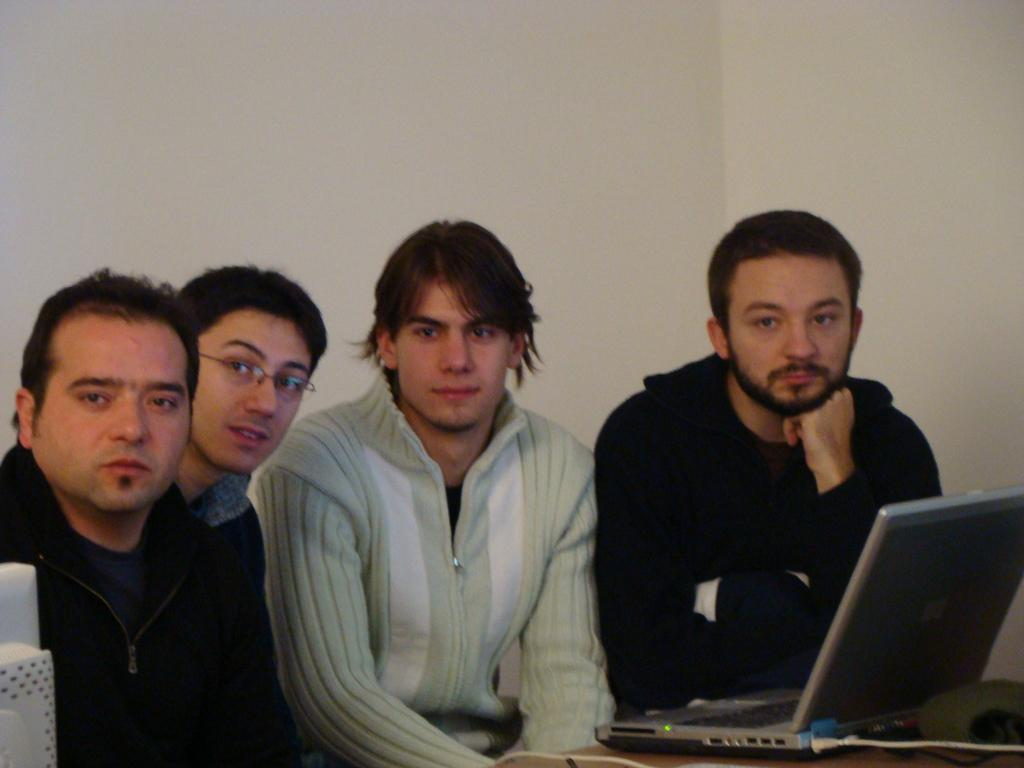What electronic device is visible in the image? There is a laptop in the image. What else can be seen on the table in the image? There are a few things on the table in the image. How many people are present in the image? There are four people in the image. What can be seen in the background of the image? There are walls visible in the background of the image. What type of letter is being written on the potato in the image? There is no potato or letter-writing activity present in the image. 